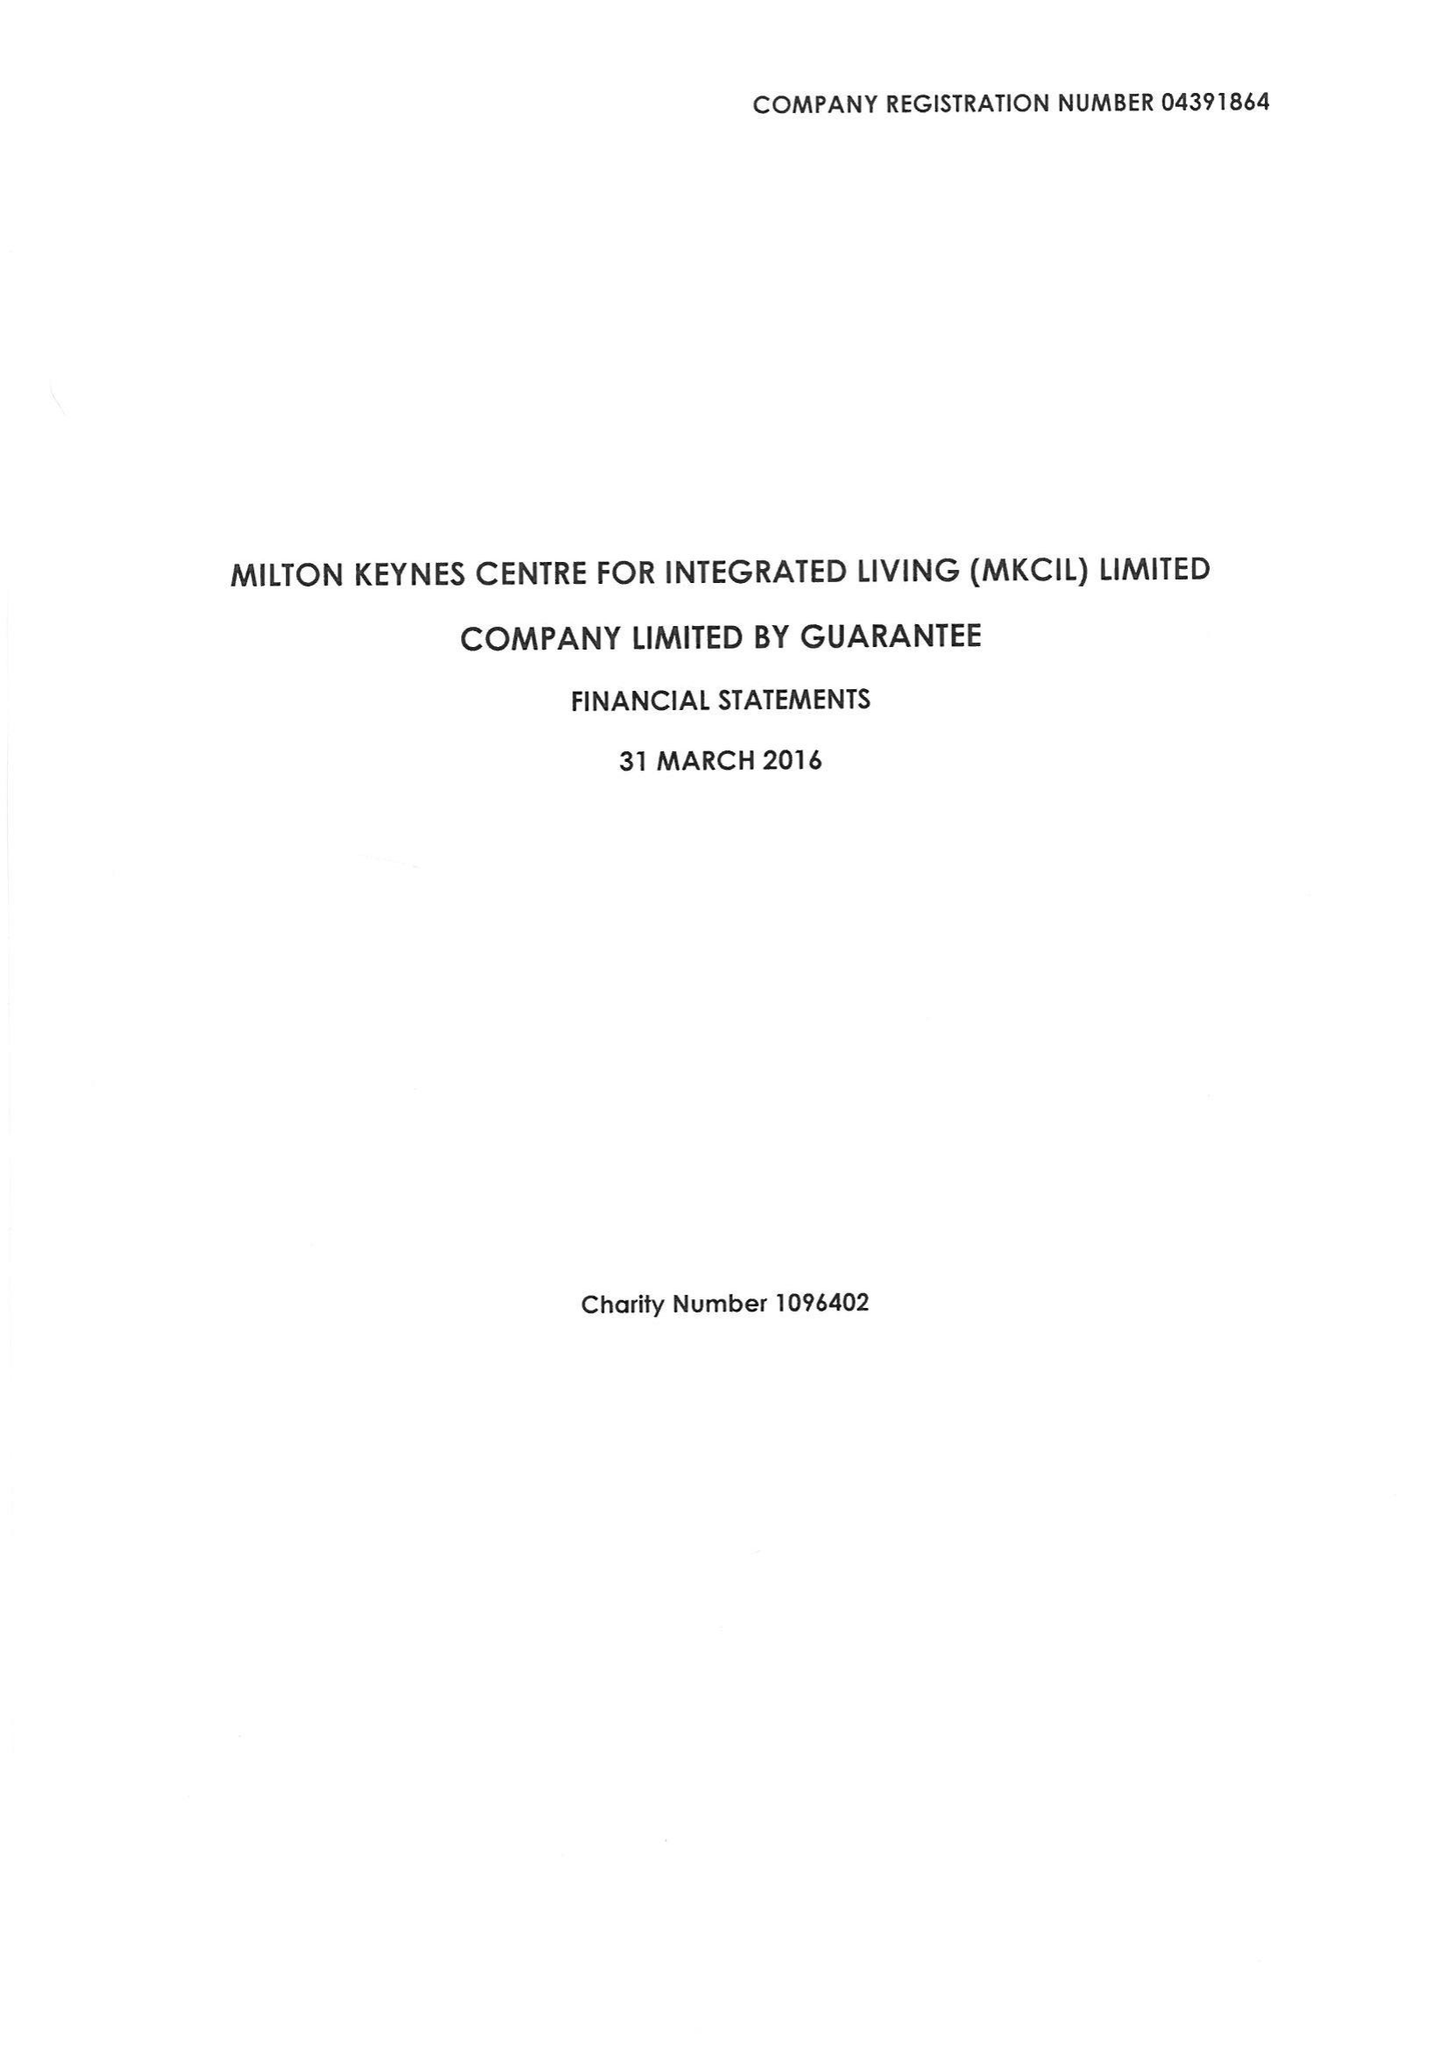What is the value for the address__street_line?
Answer the question using a single word or phrase. None 